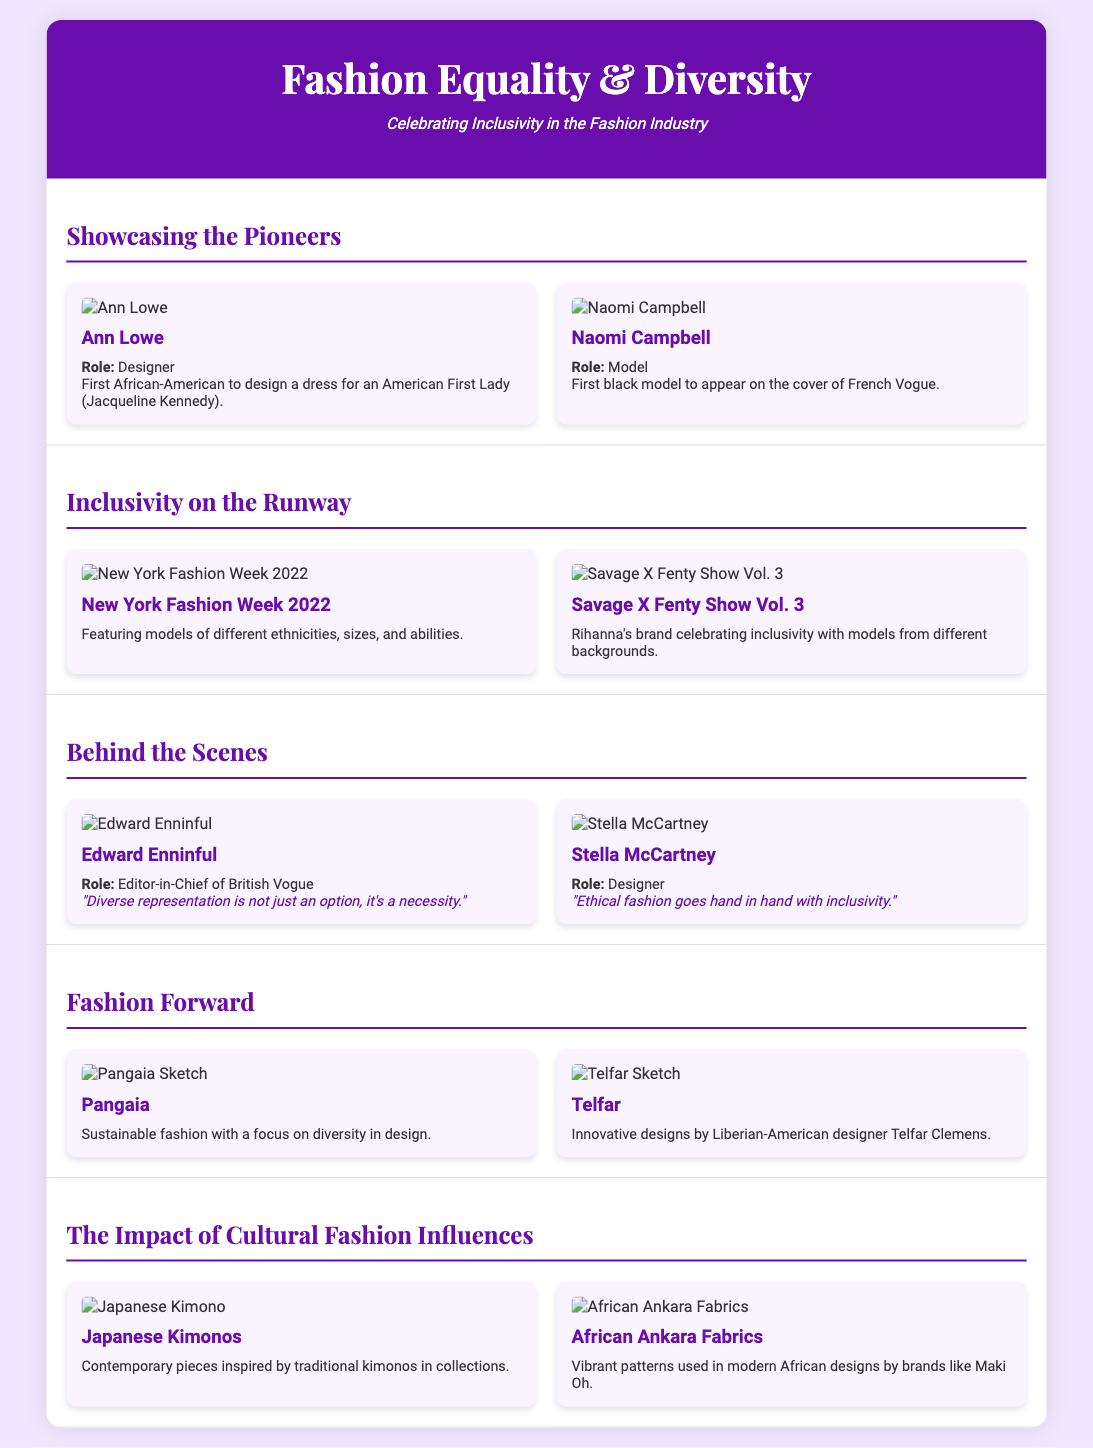what is the role of Ann Lowe? Ann Lowe is described as a designer in the document.
Answer: Designer who was the first black model on the cover of French Vogue? The document states that Naomi Campbell was the first black model on the cover of French Vogue.
Answer: Naomi Campbell which fashion show focused on models of different ethnicities, sizes, and abilities? The New York Fashion Week 2022 is noted for featuring models of diverse ethnic backgrounds and body types.
Answer: New York Fashion Week 2022 who is the Editor-in-Chief of British Vogue? The document identifies Edward Enninful as the Editor-in-Chief of British Vogue.
Answer: Edward Enninful what is Telfar known for? Telfar is highlighted for its innovative designs by Liberian-American designer Telfar Clemens.
Answer: Innovative designs which traditional garment is showcased as having contemporary adaptations? Japanese Kimonos are mentioned for being inspired by traditional styles in modern collections.
Answer: Japanese Kimonos how does Stella McCartney view ethical fashion? Stella McCartney believes that ethical fashion goes hand in hand with inclusivity, according to her quote in the document.
Answer: Inclusivity what is the primary focus of Pangaia as mentioned in the document? Pangaia focuses on sustainable fashion with a diversity emphasis in design.
Answer: Sustainable fashion what does the term "Savage X Fenty Show Vol. 3" refer to? The document discusses it as a fashion show celebrating inclusivity with models from diverse backgrounds.
Answer: A fashion show what type of fabrics are highlighted in African designs? The document mentions African Ankara fabrics for their vibrant patterns in modern African designs.
Answer: Ankara fabrics 